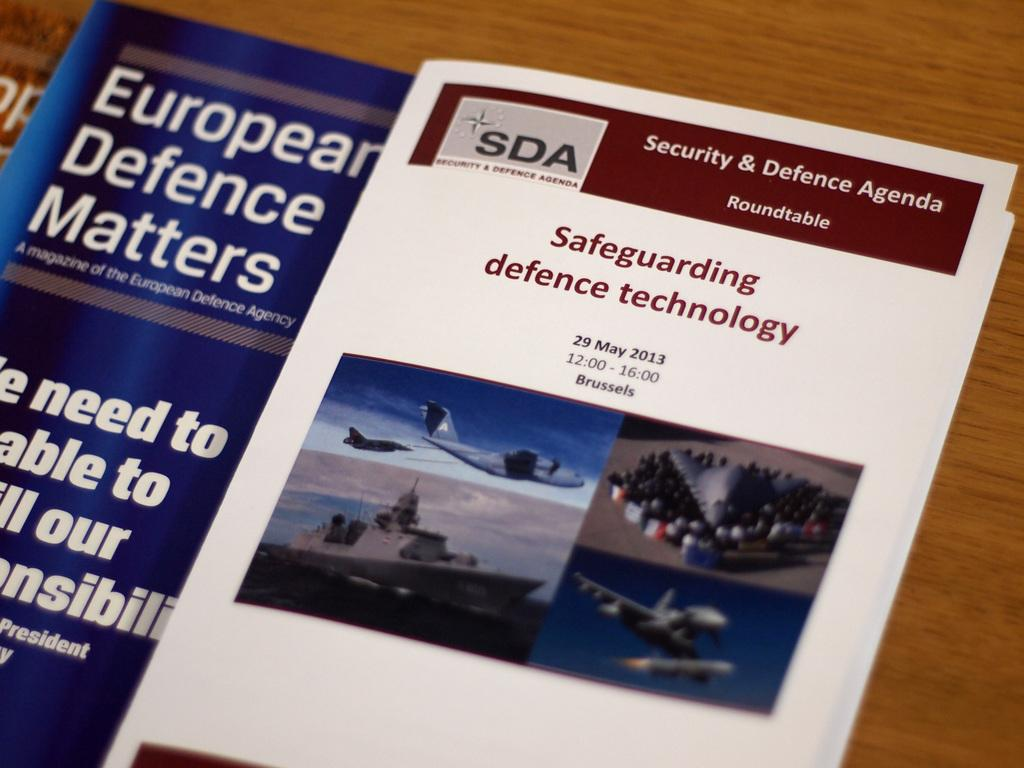<image>
Give a short and clear explanation of the subsequent image. A magazine about safeguarding defence technology is shown. 